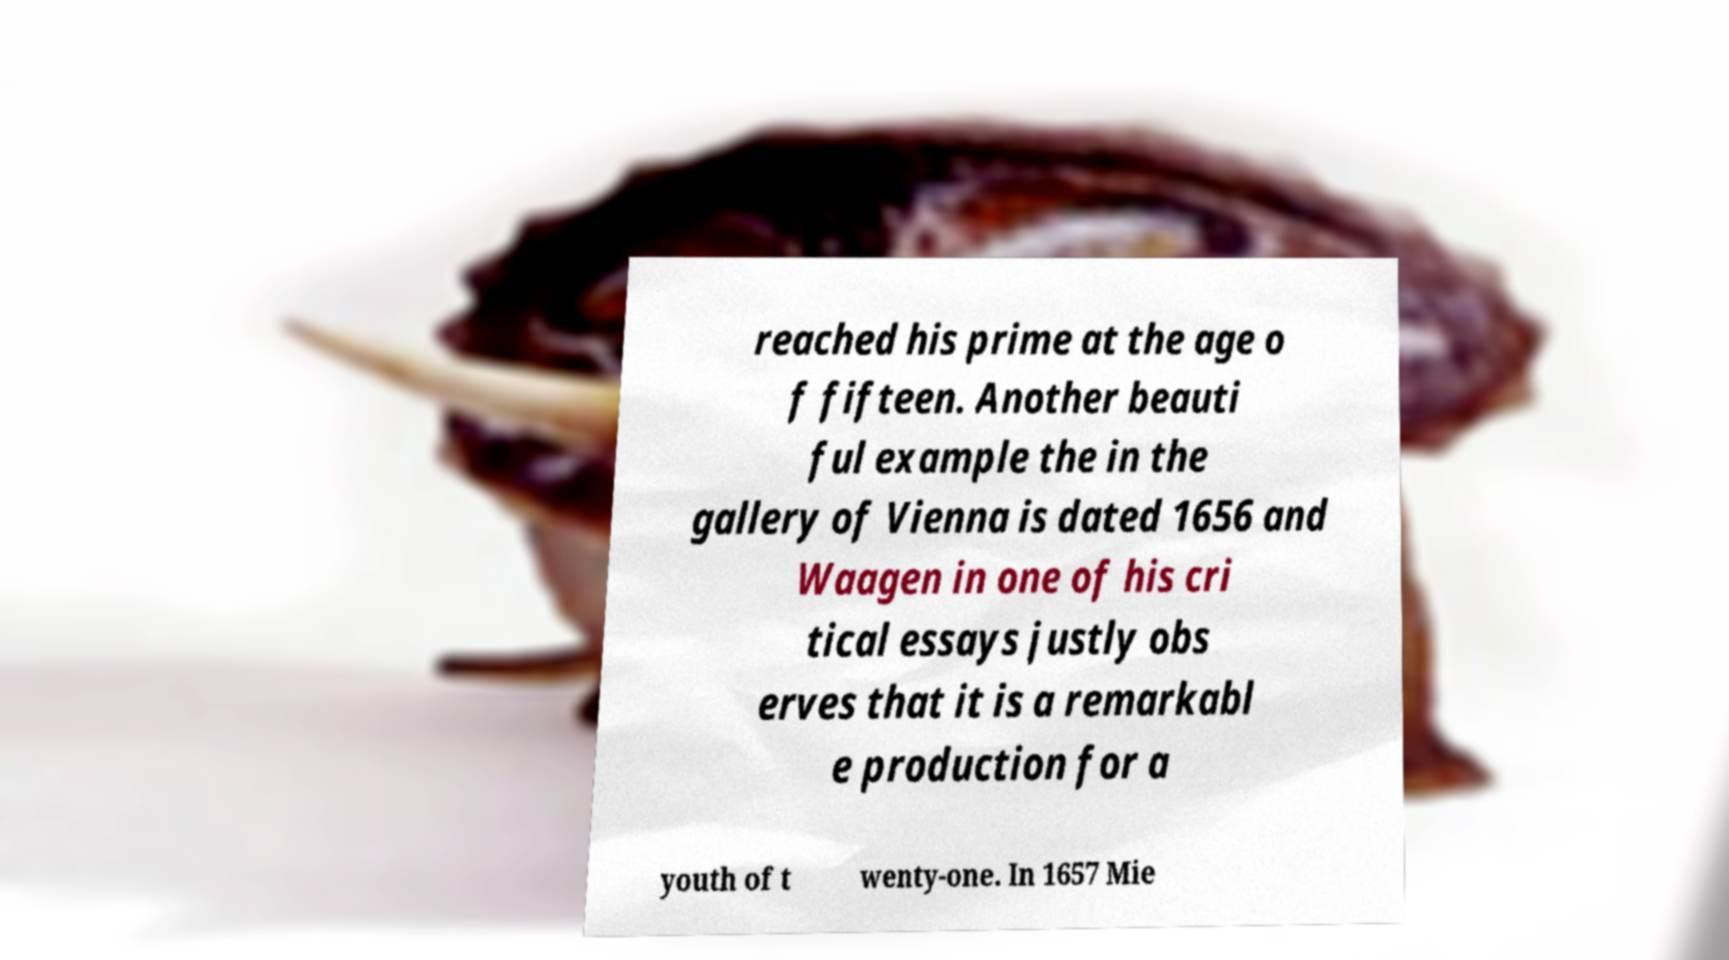Could you extract and type out the text from this image? reached his prime at the age o f fifteen. Another beauti ful example the in the gallery of Vienna is dated 1656 and Waagen in one of his cri tical essays justly obs erves that it is a remarkabl e production for a youth of t wenty-one. In 1657 Mie 